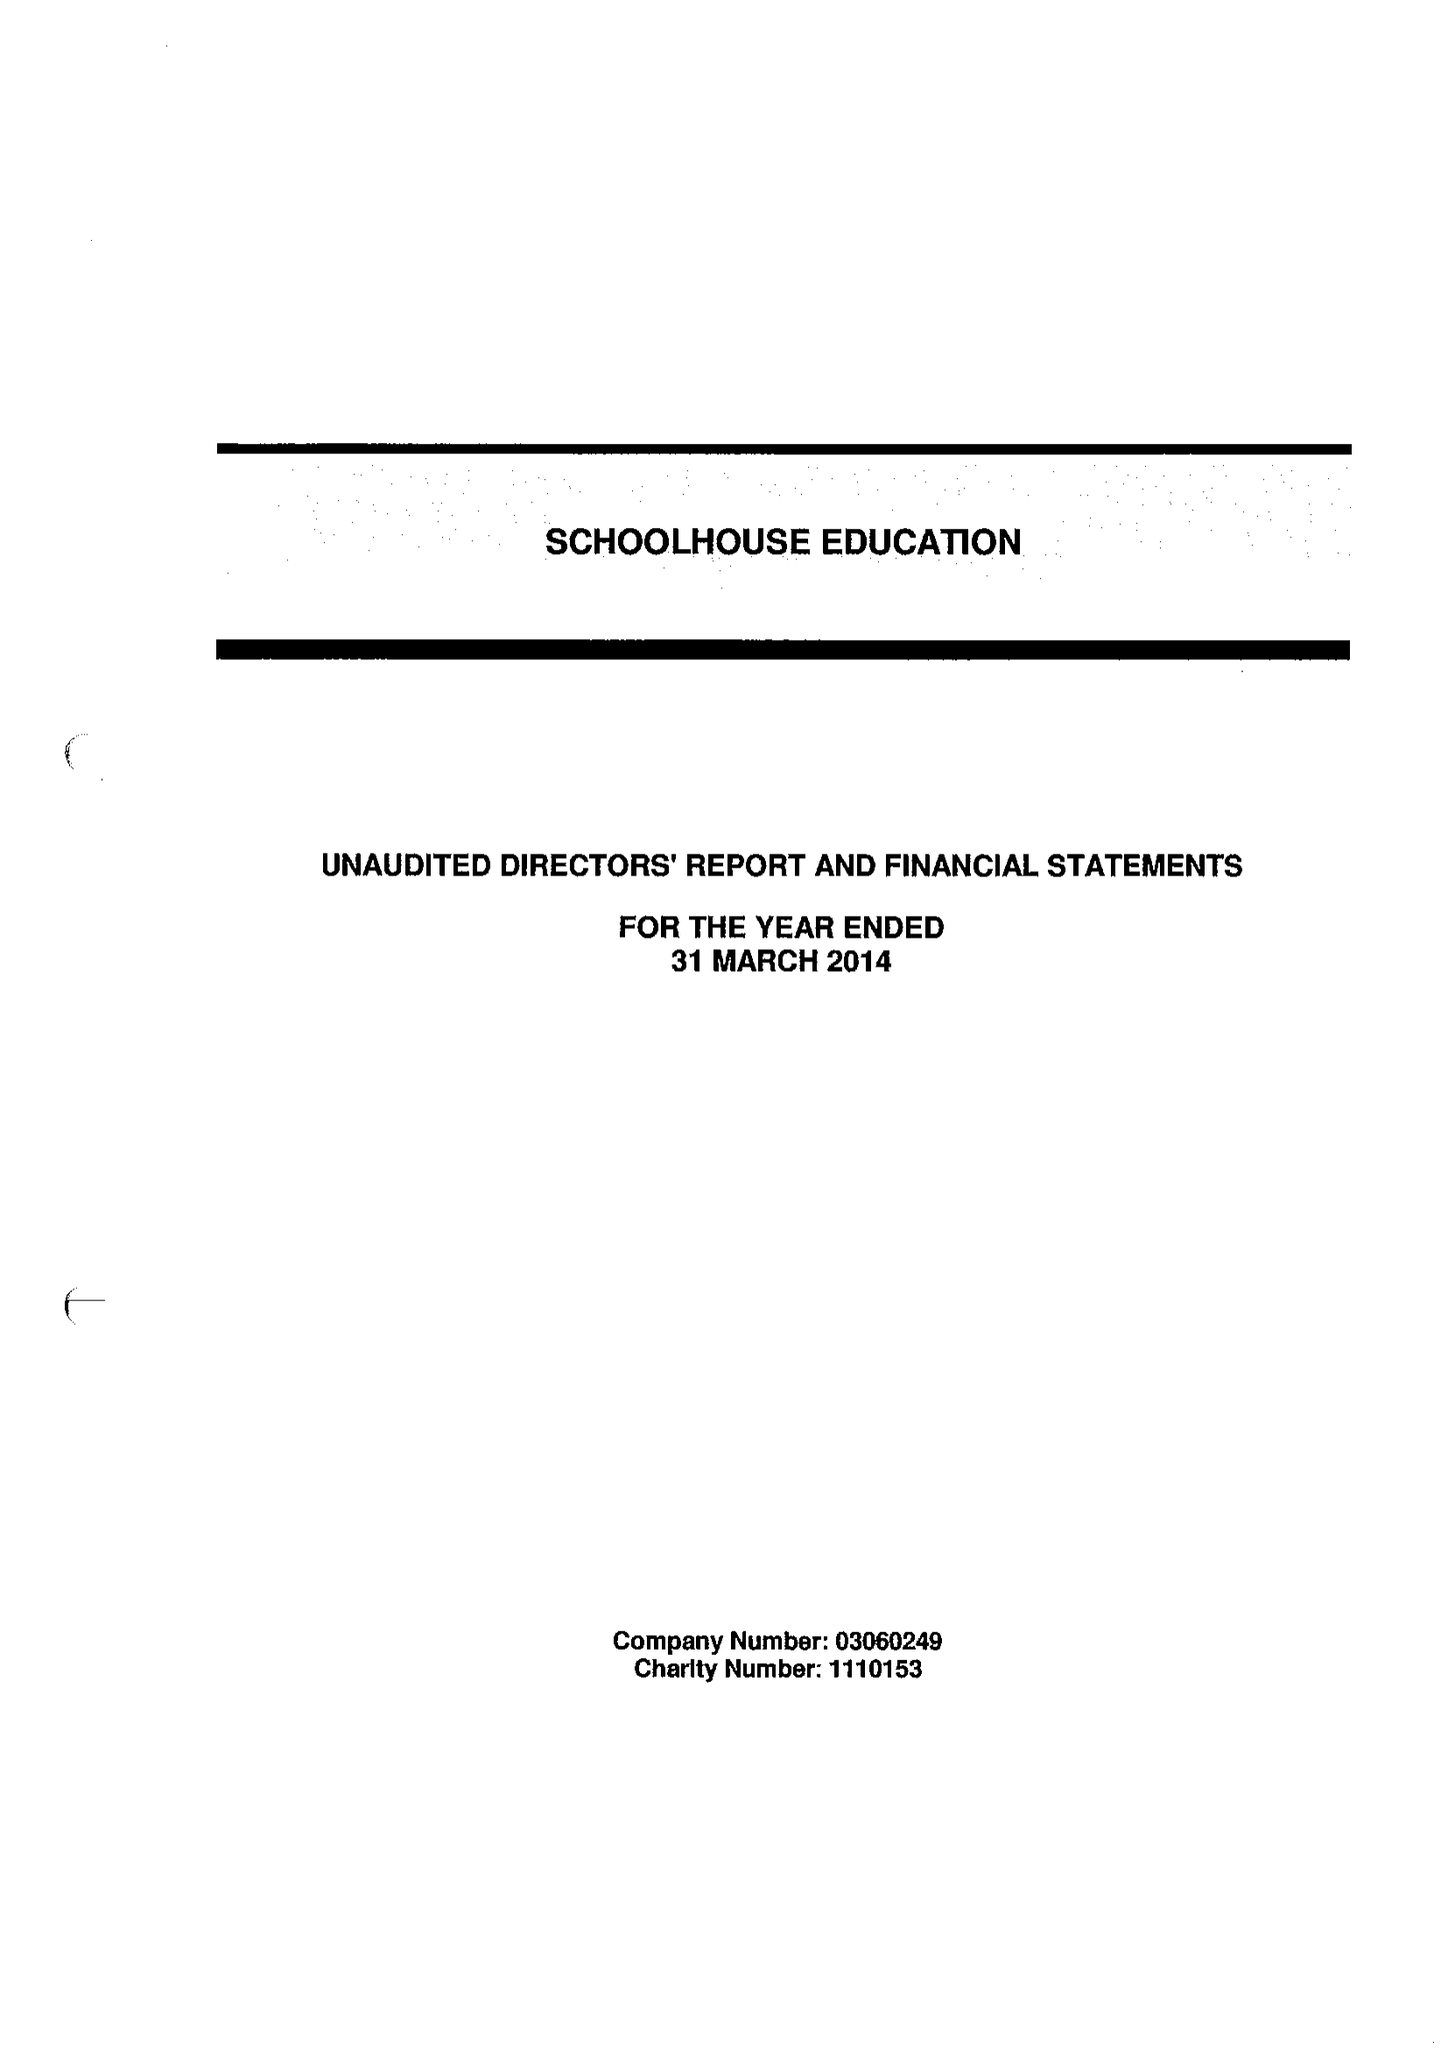What is the value for the spending_annually_in_british_pounds?
Answer the question using a single word or phrase. 384214.00 